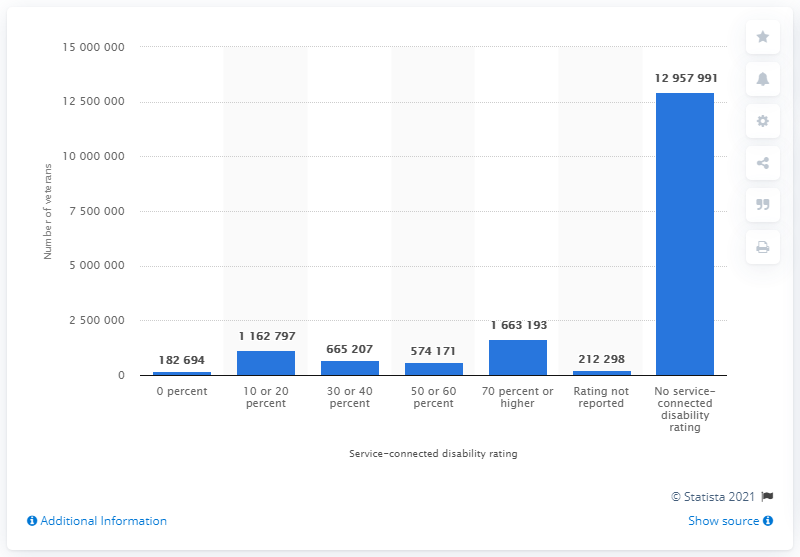Give some essential details in this illustration. In 2019, there were 166,319 veterans who had a service-connected disability rating of 70 percent or higher. 